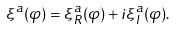Convert formula to latex. <formula><loc_0><loc_0><loc_500><loc_500>\xi ^ { a } ( \varphi ) = \xi _ { R } ^ { a } ( \varphi ) + i \xi _ { I } ^ { a } ( \varphi ) .</formula> 